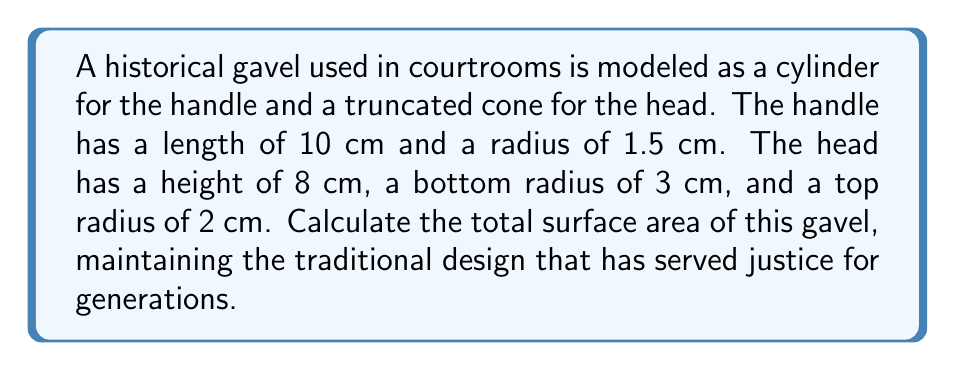Provide a solution to this math problem. Let's approach this problem step-by-step, maintaining the established methods:

1. Calculate the surface area of the handle (cylinder):
   - Lateral surface area: $A_l = 2\pi rh$
   - Circular ends: $A_c = 2\pi r^2$
   $$A_{handle} = 2\pi r(h + r) = 2\pi(1.5)(10 + 1.5) = 108.38 \text{ cm}^2$$

2. Calculate the surface area of the head (truncated cone):
   - Lateral surface area: $A_l = \pi(r_1 + r_2)\sqrt{h^2 + (r_1 - r_2)^2}$
   - Circular ends: $A_c = \pi(r_1^2 + r_2^2)$
   $$\begin{align}
   A_{head} &= \pi(3 + 2)\sqrt{8^2 + (3 - 2)^2} + \pi(3^2 + 2^2) \\
   &= 5\pi\sqrt{65} + 13\pi \\
   &= 131.71 \text{ cm}^2
   \end{align}$$

3. Sum the surface areas:
   $$A_{total} = A_{handle} + A_{head} = 108.38 + 131.71 = 240.09 \text{ cm}^2$$

[asy]
import geometry;

// Handle
draw((0,0)--(0,10), linewidth(2));
draw((3,0)--(3,10), linewidth(2));
draw((0,0)--(3,0), linewidth(2));
draw((0,10)--(3,10), linewidth(2));

// Head
draw((3,10)--(9,10), linewidth(2));
draw((3,18)--(7,18), linewidth(2));
draw((3,10)--(3,18), linewidth(2));
draw((9,10)--(7,18), linewidth(2));

label("10 cm", (1.5,5), E);
label("8 cm", (3,14), E);
label("3 cm", (6,9), S);
label("2 cm", (5,18), N);
label("1.5 cm", (0,0), W);

[/asy]
Answer: 240.09 cm² 